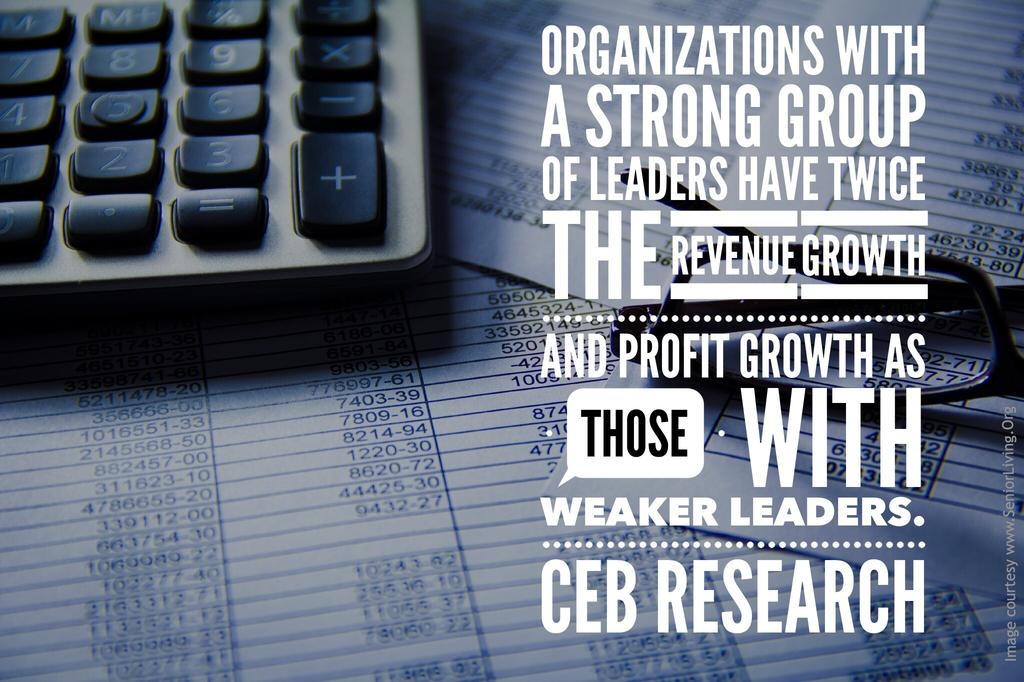<image>
Render a clear and concise summary of the photo. A calculator is sitting on spreadsheets in this CEB Research ad. 